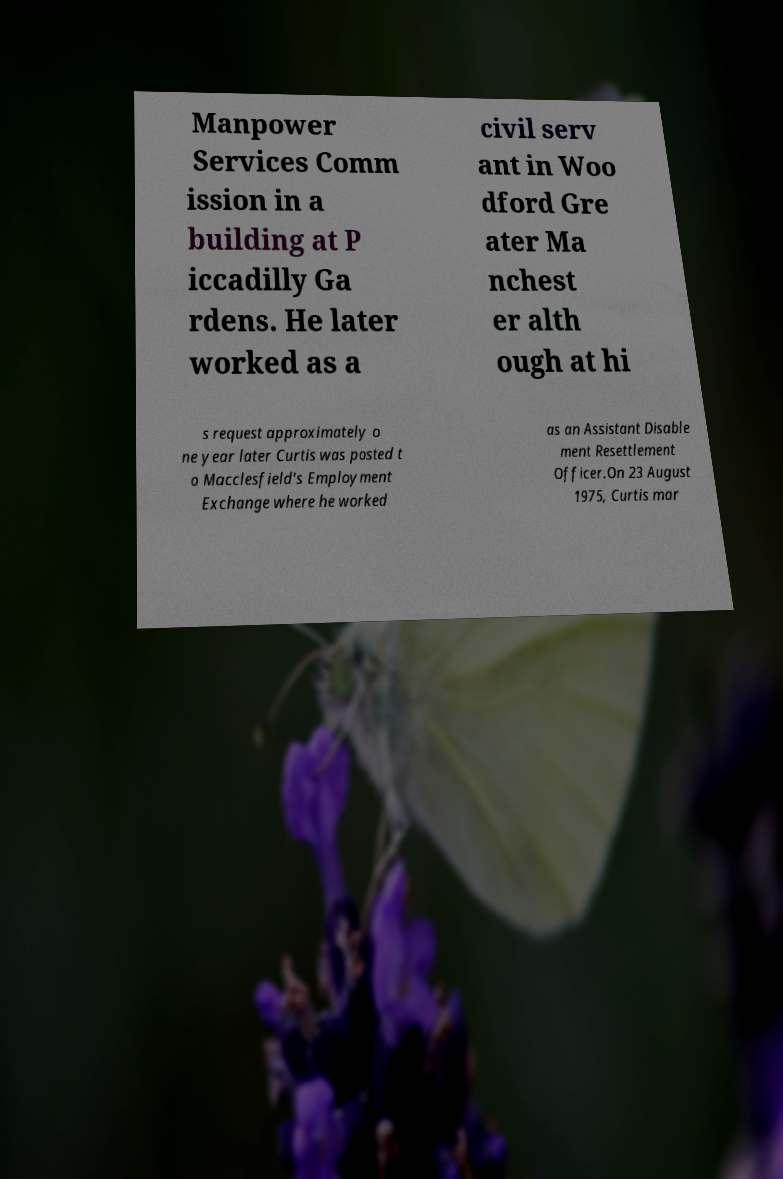Could you assist in decoding the text presented in this image and type it out clearly? Manpower Services Comm ission in a building at P iccadilly Ga rdens. He later worked as a civil serv ant in Woo dford Gre ater Ma nchest er alth ough at hi s request approximately o ne year later Curtis was posted t o Macclesfield's Employment Exchange where he worked as an Assistant Disable ment Resettlement Officer.On 23 August 1975, Curtis mar 